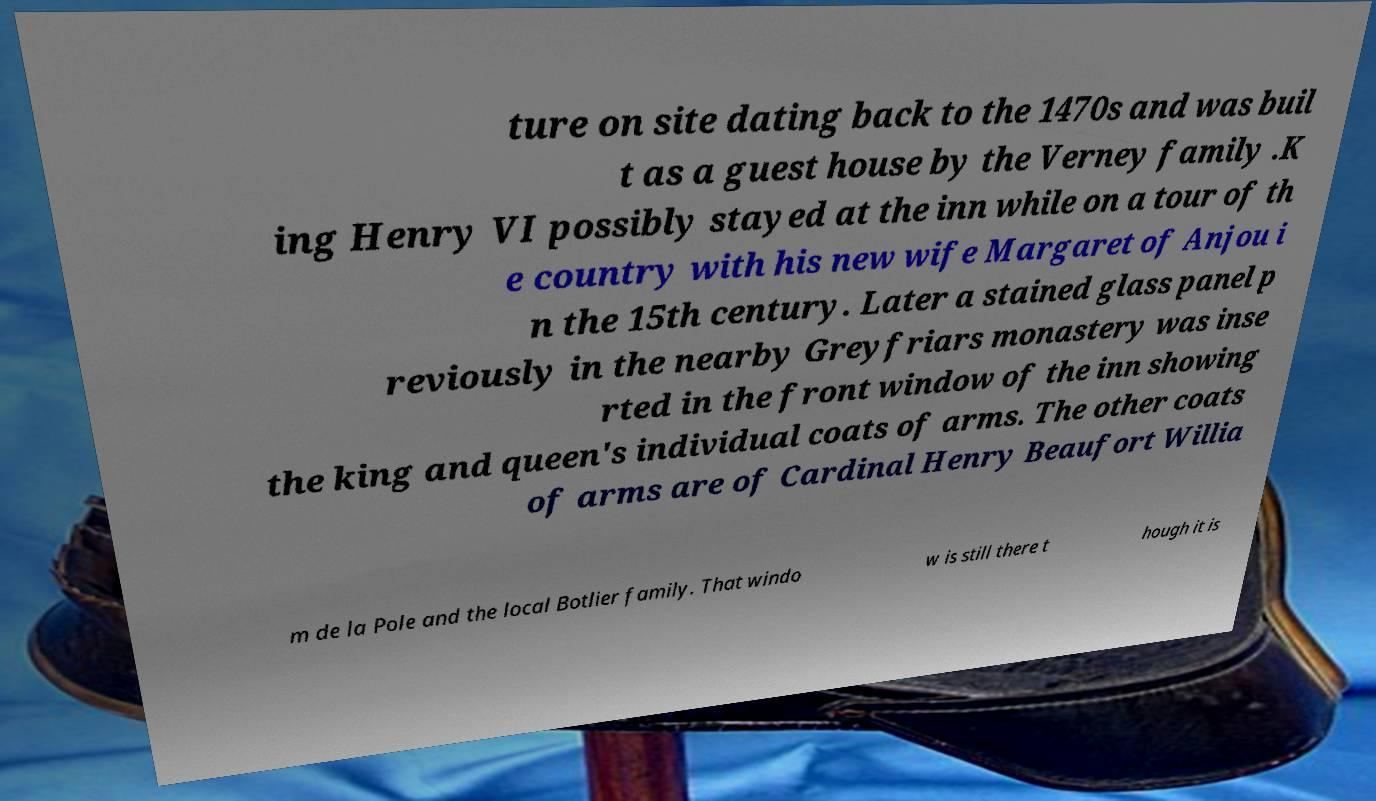I need the written content from this picture converted into text. Can you do that? ture on site dating back to the 1470s and was buil t as a guest house by the Verney family .K ing Henry VI possibly stayed at the inn while on a tour of th e country with his new wife Margaret of Anjou i n the 15th century. Later a stained glass panel p reviously in the nearby Greyfriars monastery was inse rted in the front window of the inn showing the king and queen's individual coats of arms. The other coats of arms are of Cardinal Henry Beaufort Willia m de la Pole and the local Botlier family. That windo w is still there t hough it is 